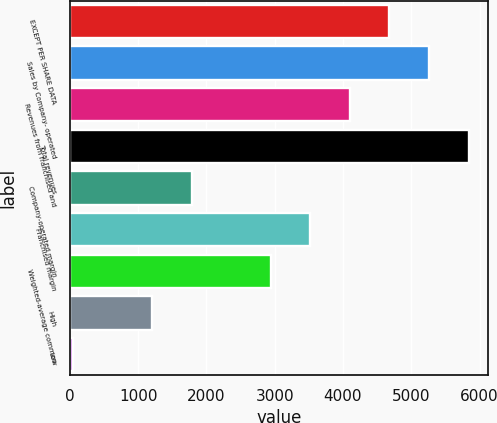Convert chart. <chart><loc_0><loc_0><loc_500><loc_500><bar_chart><fcel>EXCEPT PER SHARE DATA<fcel>Sales by Company- operated<fcel>Revenues from franchised and<fcel>Total revenues<fcel>Company-operated margin<fcel>Franchised margin<fcel>Weighted-average common<fcel>High<fcel>Low<nl><fcel>4680.34<fcel>5259.85<fcel>4100.83<fcel>5839.4<fcel>1782.79<fcel>3521.32<fcel>2941.81<fcel>1203.28<fcel>44.26<nl></chart> 